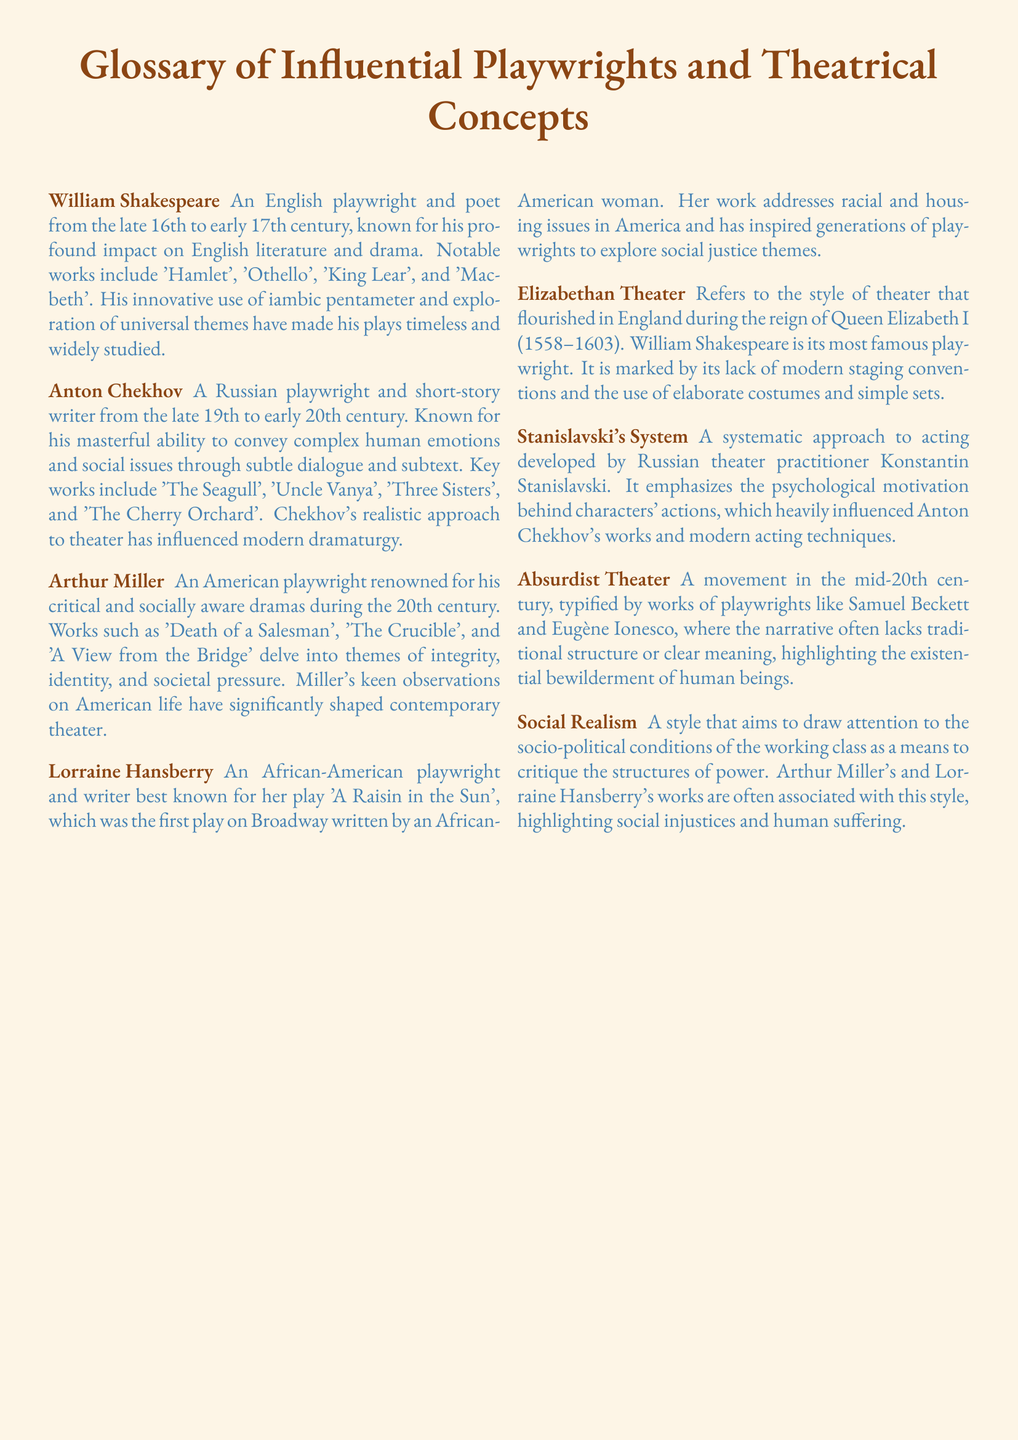What is Anton Chekhov known for? Anton Chekhov is known for his masterful ability to convey complex human emotions and social issues through subtle dialogue and subtext.
Answer: Complex human emotions What is the first play on Broadway written by an African-American woman? The first play on Broadway written by an African-American woman is 'A Raisin in the Sun'.
Answer: A Raisin in the Sun Which playwright wrote 'Death of a Salesman'? 'Death of a Salesman' was written by Arthur Miller.
Answer: Arthur Miller What era does Elizabethan Theater refer to? Elizabethan Theater refers to the style of theater that flourished during the reign of Queen Elizabeth I.
Answer: Reign of Queen Elizabeth I Which playwright's works are associated with Social Realism? Arthur Miller's and Lorraine Hansberry's works are associated with Social Realism.
Answer: Arthur Miller and Lorraine Hansberry What is the key theme of Shakespeare's plays? Shakespeare's plays explore universal themes that have made them timeless and widely studied.
Answer: Universal themes Who developed Stanislavski's System? Stanislavski's System was developed by Konstantin Stanislavski.
Answer: Konstantin Stanislavski What theatrical movement is characterized by a lack of clear meaning? The Absurdist Theater movement is characterized by a lack of clear meaning.
Answer: Absurdist Theater 